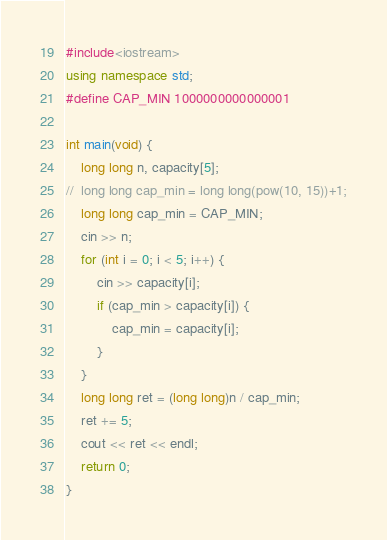<code> <loc_0><loc_0><loc_500><loc_500><_C++_>#include<iostream>
using namespace std;
#define CAP_MIN 1000000000000001

int main(void) {
	long long n, capacity[5];
//	long long cap_min = long long(pow(10, 15))+1;
	long long cap_min = CAP_MIN;
	cin >> n;
	for (int i = 0; i < 5; i++) {
		cin >> capacity[i];
		if (cap_min > capacity[i]) {
			cap_min = capacity[i];
		}
	}
	long long ret = (long long)n / cap_min;
	ret += 5;
	cout << ret << endl;
	return 0;
}</code> 